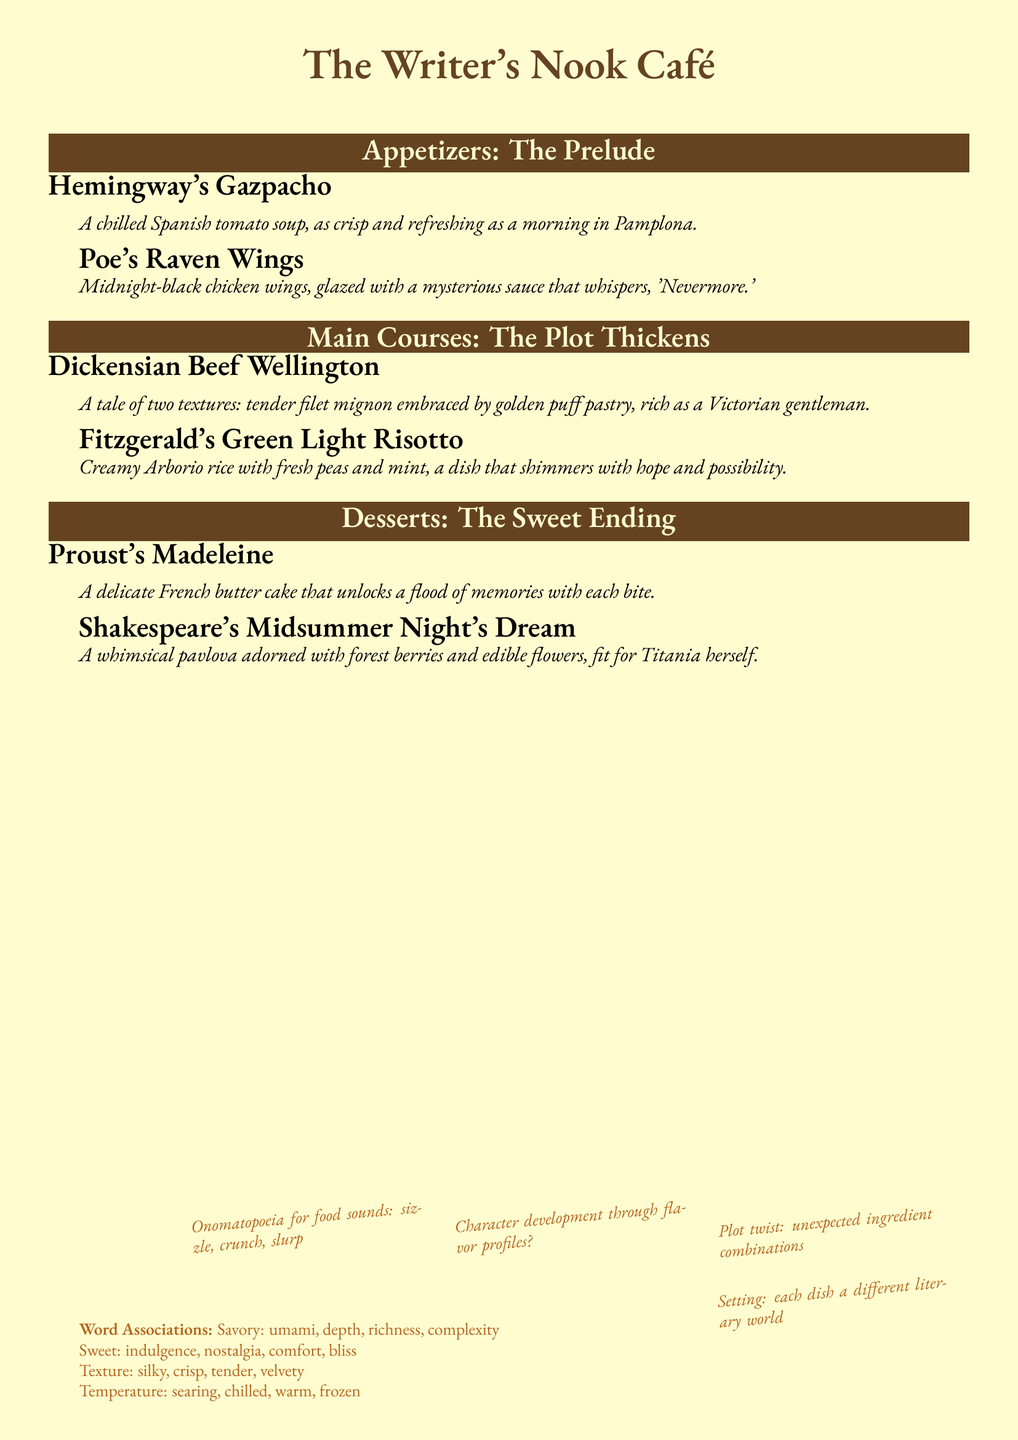What are the appetizers? The list of appetizers includes "Hemingway's Gazpacho" and "Poe's Raven Wings."
Answer: Hemingway's Gazpacho, Poe's Raven Wings What is the main feature of Fitzgerald's Green Light Risotto? The dish is characterized by creamy Arborio rice with fresh peas and mint, symbolizing hope and possibility.
Answer: Creamy Arborio rice with fresh peas and mint How many main courses are listed? The document includes a total of two main courses.
Answer: Two Which dessert is associated with Proust? The dessert linked to Proust in the menu is a madeleine, a French butter cake.
Answer: Proust's Madeleine What color is the menu’s background? The color used for the background of the menu is cream.
Answer: Cream What literary element is suggested by the scribbled notes? The notes indicate that character development can be expressed through flavor profiles in the dishes.
Answer: Flavor profiles Which literary figure is referenced with the dessert named after a whimsical creation? The dessert "Shakespeare's Midsummer Night's Dream" references Shakespeare.
Answer: Shakespeare What word follows "Savory" in the word associations? The word that follows "Savory" is "umami."
Answer: Umami 